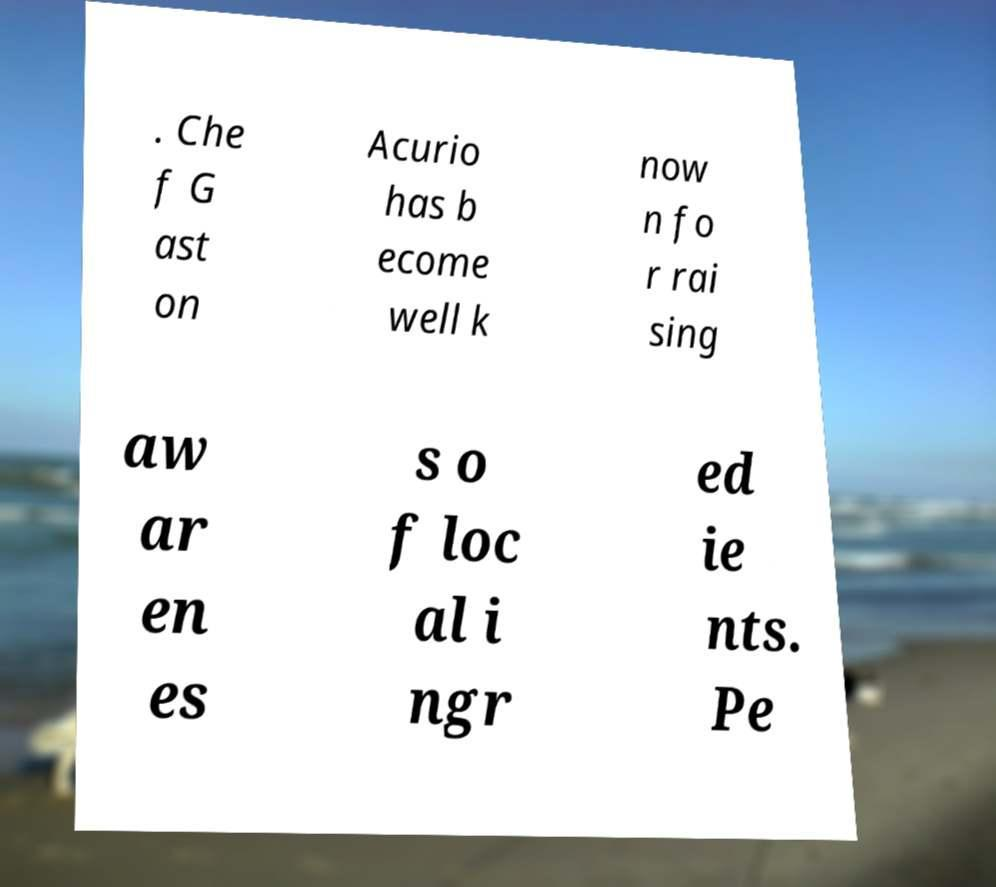Could you extract and type out the text from this image? . Che f G ast on Acurio has b ecome well k now n fo r rai sing aw ar en es s o f loc al i ngr ed ie nts. Pe 